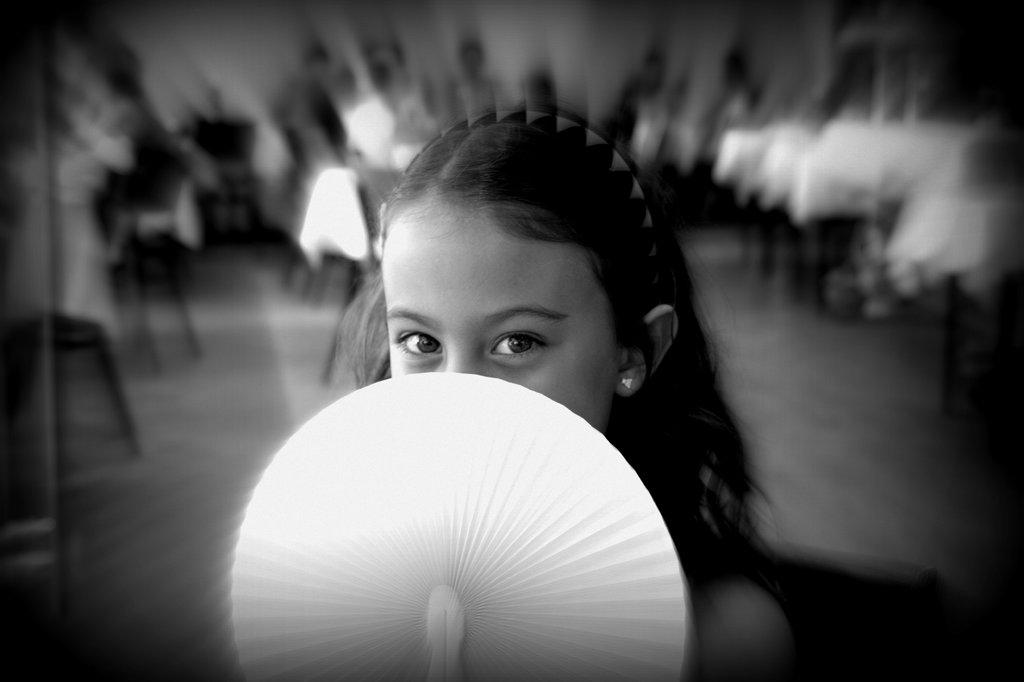What is the color scheme of the image? The image is black and white. Who is the main subject in the image? There is a girl standing in the center of the image. What is the girl holding in the image? The girl is holding an object. What can be seen in the background of the image? There are persons and chairs in the background of the image. What type of feast is being prepared in the image? There is no indication of a feast or any food preparation in the image. How much does the plough weigh that the girl is holding in the image? There is no plough present in the image; the girl is holding an unspecified object. 